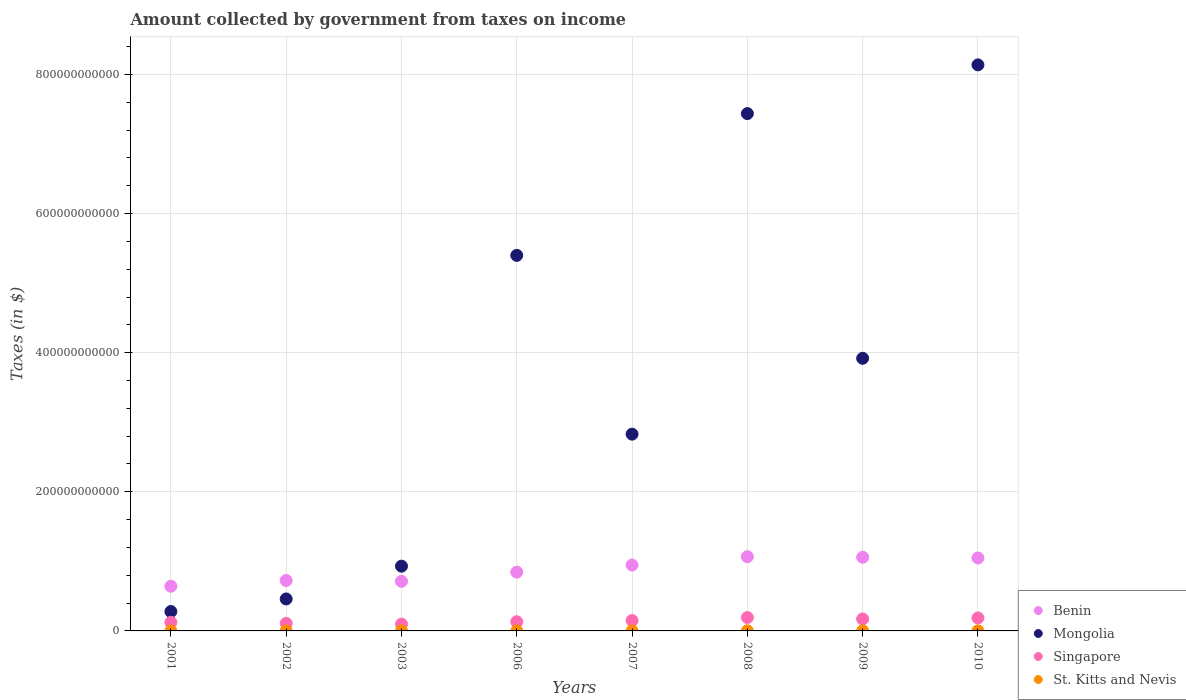How many different coloured dotlines are there?
Give a very brief answer. 4. Is the number of dotlines equal to the number of legend labels?
Provide a succinct answer. Yes. What is the amount collected by government from taxes on income in Benin in 2010?
Give a very brief answer. 1.05e+11. Across all years, what is the maximum amount collected by government from taxes on income in St. Kitts and Nevis?
Give a very brief answer. 1.48e+08. Across all years, what is the minimum amount collected by government from taxes on income in Mongolia?
Make the answer very short. 2.79e+1. In which year was the amount collected by government from taxes on income in Benin maximum?
Provide a succinct answer. 2008. In which year was the amount collected by government from taxes on income in Singapore minimum?
Provide a succinct answer. 2003. What is the total amount collected by government from taxes on income in St. Kitts and Nevis in the graph?
Your answer should be compact. 7.73e+08. What is the difference between the amount collected by government from taxes on income in Singapore in 2003 and that in 2010?
Offer a terse response. -8.86e+09. What is the difference between the amount collected by government from taxes on income in Singapore in 2002 and the amount collected by government from taxes on income in Benin in 2001?
Make the answer very short. -5.34e+1. What is the average amount collected by government from taxes on income in Mongolia per year?
Ensure brevity in your answer.  3.67e+11. In the year 2010, what is the difference between the amount collected by government from taxes on income in Singapore and amount collected by government from taxes on income in Mongolia?
Offer a very short reply. -7.95e+11. In how many years, is the amount collected by government from taxes on income in Benin greater than 400000000000 $?
Your answer should be very brief. 0. What is the ratio of the amount collected by government from taxes on income in Benin in 2002 to that in 2003?
Make the answer very short. 1.02. Is the amount collected by government from taxes on income in Singapore in 2001 less than that in 2007?
Give a very brief answer. Yes. What is the difference between the highest and the second highest amount collected by government from taxes on income in Benin?
Your answer should be very brief. 8.11e+08. What is the difference between the highest and the lowest amount collected by government from taxes on income in Singapore?
Your response must be concise. 9.47e+09. In how many years, is the amount collected by government from taxes on income in St. Kitts and Nevis greater than the average amount collected by government from taxes on income in St. Kitts and Nevis taken over all years?
Offer a terse response. 4. Does the amount collected by government from taxes on income in Benin monotonically increase over the years?
Give a very brief answer. No. Is the amount collected by government from taxes on income in Mongolia strictly less than the amount collected by government from taxes on income in Benin over the years?
Your answer should be very brief. No. How many years are there in the graph?
Keep it short and to the point. 8. What is the difference between two consecutive major ticks on the Y-axis?
Your response must be concise. 2.00e+11. Where does the legend appear in the graph?
Offer a terse response. Bottom right. How are the legend labels stacked?
Provide a succinct answer. Vertical. What is the title of the graph?
Keep it short and to the point. Amount collected by government from taxes on income. Does "Pacific island small states" appear as one of the legend labels in the graph?
Ensure brevity in your answer.  No. What is the label or title of the X-axis?
Offer a terse response. Years. What is the label or title of the Y-axis?
Provide a succinct answer. Taxes (in $). What is the Taxes (in $) in Benin in 2001?
Your answer should be compact. 6.43e+1. What is the Taxes (in $) of Mongolia in 2001?
Keep it short and to the point. 2.79e+1. What is the Taxes (in $) in Singapore in 2001?
Offer a terse response. 1.24e+1. What is the Taxes (in $) in St. Kitts and Nevis in 2001?
Provide a short and direct response. 5.77e+07. What is the Taxes (in $) in Benin in 2002?
Your response must be concise. 7.25e+1. What is the Taxes (in $) of Mongolia in 2002?
Provide a succinct answer. 4.60e+1. What is the Taxes (in $) of Singapore in 2002?
Make the answer very short. 1.09e+1. What is the Taxes (in $) in St. Kitts and Nevis in 2002?
Provide a succinct answer. 6.19e+07. What is the Taxes (in $) in Benin in 2003?
Make the answer very short. 7.13e+1. What is the Taxes (in $) of Mongolia in 2003?
Offer a terse response. 9.31e+1. What is the Taxes (in $) of Singapore in 2003?
Make the answer very short. 9.78e+09. What is the Taxes (in $) of St. Kitts and Nevis in 2003?
Your answer should be compact. 6.41e+07. What is the Taxes (in $) in Benin in 2006?
Provide a succinct answer. 8.45e+1. What is the Taxes (in $) of Mongolia in 2006?
Your answer should be compact. 5.40e+11. What is the Taxes (in $) of Singapore in 2006?
Offer a terse response. 1.32e+1. What is the Taxes (in $) of St. Kitts and Nevis in 2006?
Offer a terse response. 9.84e+07. What is the Taxes (in $) of Benin in 2007?
Offer a terse response. 9.47e+1. What is the Taxes (in $) of Mongolia in 2007?
Make the answer very short. 2.83e+11. What is the Taxes (in $) of Singapore in 2007?
Offer a very short reply. 1.49e+1. What is the Taxes (in $) of St. Kitts and Nevis in 2007?
Provide a succinct answer. 1.16e+08. What is the Taxes (in $) of Benin in 2008?
Keep it short and to the point. 1.07e+11. What is the Taxes (in $) in Mongolia in 2008?
Give a very brief answer. 7.44e+11. What is the Taxes (in $) in Singapore in 2008?
Your answer should be compact. 1.93e+1. What is the Taxes (in $) in St. Kitts and Nevis in 2008?
Your response must be concise. 1.35e+08. What is the Taxes (in $) in Benin in 2009?
Keep it short and to the point. 1.06e+11. What is the Taxes (in $) in Mongolia in 2009?
Provide a succinct answer. 3.92e+11. What is the Taxes (in $) of Singapore in 2009?
Provide a short and direct response. 1.72e+1. What is the Taxes (in $) in St. Kitts and Nevis in 2009?
Your answer should be very brief. 1.48e+08. What is the Taxes (in $) in Benin in 2010?
Offer a very short reply. 1.05e+11. What is the Taxes (in $) of Mongolia in 2010?
Give a very brief answer. 8.14e+11. What is the Taxes (in $) of Singapore in 2010?
Provide a short and direct response. 1.86e+1. What is the Taxes (in $) in St. Kitts and Nevis in 2010?
Your response must be concise. 9.26e+07. Across all years, what is the maximum Taxes (in $) of Benin?
Make the answer very short. 1.07e+11. Across all years, what is the maximum Taxes (in $) in Mongolia?
Make the answer very short. 8.14e+11. Across all years, what is the maximum Taxes (in $) of Singapore?
Ensure brevity in your answer.  1.93e+1. Across all years, what is the maximum Taxes (in $) in St. Kitts and Nevis?
Make the answer very short. 1.48e+08. Across all years, what is the minimum Taxes (in $) in Benin?
Your response must be concise. 6.43e+1. Across all years, what is the minimum Taxes (in $) of Mongolia?
Provide a short and direct response. 2.79e+1. Across all years, what is the minimum Taxes (in $) of Singapore?
Your answer should be compact. 9.78e+09. Across all years, what is the minimum Taxes (in $) of St. Kitts and Nevis?
Offer a terse response. 5.77e+07. What is the total Taxes (in $) of Benin in the graph?
Provide a short and direct response. 7.05e+11. What is the total Taxes (in $) of Mongolia in the graph?
Provide a succinct answer. 2.94e+12. What is the total Taxes (in $) of Singapore in the graph?
Ensure brevity in your answer.  1.16e+11. What is the total Taxes (in $) of St. Kitts and Nevis in the graph?
Ensure brevity in your answer.  7.73e+08. What is the difference between the Taxes (in $) in Benin in 2001 and that in 2002?
Give a very brief answer. -8.23e+09. What is the difference between the Taxes (in $) of Mongolia in 2001 and that in 2002?
Make the answer very short. -1.81e+1. What is the difference between the Taxes (in $) of Singapore in 2001 and that in 2002?
Offer a very short reply. 1.50e+09. What is the difference between the Taxes (in $) in St. Kitts and Nevis in 2001 and that in 2002?
Ensure brevity in your answer.  -4.20e+06. What is the difference between the Taxes (in $) in Benin in 2001 and that in 2003?
Keep it short and to the point. -7.04e+09. What is the difference between the Taxes (in $) in Mongolia in 2001 and that in 2003?
Give a very brief answer. -6.52e+1. What is the difference between the Taxes (in $) of Singapore in 2001 and that in 2003?
Your answer should be compact. 2.59e+09. What is the difference between the Taxes (in $) of St. Kitts and Nevis in 2001 and that in 2003?
Your response must be concise. -6.40e+06. What is the difference between the Taxes (in $) of Benin in 2001 and that in 2006?
Keep it short and to the point. -2.03e+1. What is the difference between the Taxes (in $) of Mongolia in 2001 and that in 2006?
Offer a terse response. -5.12e+11. What is the difference between the Taxes (in $) of Singapore in 2001 and that in 2006?
Your answer should be compact. -8.12e+08. What is the difference between the Taxes (in $) in St. Kitts and Nevis in 2001 and that in 2006?
Keep it short and to the point. -4.07e+07. What is the difference between the Taxes (in $) of Benin in 2001 and that in 2007?
Provide a succinct answer. -3.04e+1. What is the difference between the Taxes (in $) in Mongolia in 2001 and that in 2007?
Offer a very short reply. -2.55e+11. What is the difference between the Taxes (in $) in Singapore in 2001 and that in 2007?
Your answer should be compact. -2.57e+09. What is the difference between the Taxes (in $) in St. Kitts and Nevis in 2001 and that in 2007?
Your response must be concise. -5.83e+07. What is the difference between the Taxes (in $) of Benin in 2001 and that in 2008?
Provide a short and direct response. -4.24e+1. What is the difference between the Taxes (in $) in Mongolia in 2001 and that in 2008?
Offer a very short reply. -7.16e+11. What is the difference between the Taxes (in $) in Singapore in 2001 and that in 2008?
Your answer should be compact. -6.89e+09. What is the difference between the Taxes (in $) in St. Kitts and Nevis in 2001 and that in 2008?
Offer a very short reply. -7.71e+07. What is the difference between the Taxes (in $) in Benin in 2001 and that in 2009?
Give a very brief answer. -4.16e+1. What is the difference between the Taxes (in $) in Mongolia in 2001 and that in 2009?
Give a very brief answer. -3.64e+11. What is the difference between the Taxes (in $) in Singapore in 2001 and that in 2009?
Ensure brevity in your answer.  -4.81e+09. What is the difference between the Taxes (in $) in St. Kitts and Nevis in 2001 and that in 2009?
Ensure brevity in your answer.  -8.99e+07. What is the difference between the Taxes (in $) in Benin in 2001 and that in 2010?
Give a very brief answer. -4.06e+1. What is the difference between the Taxes (in $) in Mongolia in 2001 and that in 2010?
Ensure brevity in your answer.  -7.86e+11. What is the difference between the Taxes (in $) in Singapore in 2001 and that in 2010?
Provide a succinct answer. -6.28e+09. What is the difference between the Taxes (in $) in St. Kitts and Nevis in 2001 and that in 2010?
Give a very brief answer. -3.49e+07. What is the difference between the Taxes (in $) in Benin in 2002 and that in 2003?
Your answer should be very brief. 1.19e+09. What is the difference between the Taxes (in $) in Mongolia in 2002 and that in 2003?
Make the answer very short. -4.71e+1. What is the difference between the Taxes (in $) in Singapore in 2002 and that in 2003?
Your answer should be very brief. 1.09e+09. What is the difference between the Taxes (in $) in St. Kitts and Nevis in 2002 and that in 2003?
Ensure brevity in your answer.  -2.20e+06. What is the difference between the Taxes (in $) of Benin in 2002 and that in 2006?
Provide a succinct answer. -1.20e+1. What is the difference between the Taxes (in $) in Mongolia in 2002 and that in 2006?
Your response must be concise. -4.94e+11. What is the difference between the Taxes (in $) in Singapore in 2002 and that in 2006?
Provide a succinct answer. -2.31e+09. What is the difference between the Taxes (in $) in St. Kitts and Nevis in 2002 and that in 2006?
Your answer should be compact. -3.65e+07. What is the difference between the Taxes (in $) in Benin in 2002 and that in 2007?
Make the answer very short. -2.22e+1. What is the difference between the Taxes (in $) in Mongolia in 2002 and that in 2007?
Your response must be concise. -2.37e+11. What is the difference between the Taxes (in $) in Singapore in 2002 and that in 2007?
Ensure brevity in your answer.  -4.07e+09. What is the difference between the Taxes (in $) in St. Kitts and Nevis in 2002 and that in 2007?
Keep it short and to the point. -5.41e+07. What is the difference between the Taxes (in $) in Benin in 2002 and that in 2008?
Your response must be concise. -3.42e+1. What is the difference between the Taxes (in $) of Mongolia in 2002 and that in 2008?
Offer a very short reply. -6.98e+11. What is the difference between the Taxes (in $) in Singapore in 2002 and that in 2008?
Your response must be concise. -8.39e+09. What is the difference between the Taxes (in $) in St. Kitts and Nevis in 2002 and that in 2008?
Your response must be concise. -7.29e+07. What is the difference between the Taxes (in $) of Benin in 2002 and that in 2009?
Your response must be concise. -3.34e+1. What is the difference between the Taxes (in $) in Mongolia in 2002 and that in 2009?
Provide a short and direct response. -3.46e+11. What is the difference between the Taxes (in $) of Singapore in 2002 and that in 2009?
Ensure brevity in your answer.  -6.31e+09. What is the difference between the Taxes (in $) in St. Kitts and Nevis in 2002 and that in 2009?
Provide a succinct answer. -8.57e+07. What is the difference between the Taxes (in $) in Benin in 2002 and that in 2010?
Your answer should be very brief. -3.24e+1. What is the difference between the Taxes (in $) of Mongolia in 2002 and that in 2010?
Your answer should be very brief. -7.68e+11. What is the difference between the Taxes (in $) in Singapore in 2002 and that in 2010?
Your answer should be compact. -7.77e+09. What is the difference between the Taxes (in $) in St. Kitts and Nevis in 2002 and that in 2010?
Make the answer very short. -3.07e+07. What is the difference between the Taxes (in $) in Benin in 2003 and that in 2006?
Provide a short and direct response. -1.32e+1. What is the difference between the Taxes (in $) in Mongolia in 2003 and that in 2006?
Keep it short and to the point. -4.47e+11. What is the difference between the Taxes (in $) in Singapore in 2003 and that in 2006?
Your response must be concise. -3.40e+09. What is the difference between the Taxes (in $) in St. Kitts and Nevis in 2003 and that in 2006?
Provide a succinct answer. -3.43e+07. What is the difference between the Taxes (in $) of Benin in 2003 and that in 2007?
Your answer should be very brief. -2.34e+1. What is the difference between the Taxes (in $) of Mongolia in 2003 and that in 2007?
Your answer should be compact. -1.90e+11. What is the difference between the Taxes (in $) in Singapore in 2003 and that in 2007?
Your answer should be very brief. -5.16e+09. What is the difference between the Taxes (in $) in St. Kitts and Nevis in 2003 and that in 2007?
Provide a succinct answer. -5.19e+07. What is the difference between the Taxes (in $) of Benin in 2003 and that in 2008?
Your response must be concise. -3.54e+1. What is the difference between the Taxes (in $) in Mongolia in 2003 and that in 2008?
Provide a succinct answer. -6.51e+11. What is the difference between the Taxes (in $) in Singapore in 2003 and that in 2008?
Keep it short and to the point. -9.47e+09. What is the difference between the Taxes (in $) of St. Kitts and Nevis in 2003 and that in 2008?
Provide a succinct answer. -7.07e+07. What is the difference between the Taxes (in $) of Benin in 2003 and that in 2009?
Your answer should be very brief. -3.46e+1. What is the difference between the Taxes (in $) of Mongolia in 2003 and that in 2009?
Offer a terse response. -2.99e+11. What is the difference between the Taxes (in $) of Singapore in 2003 and that in 2009?
Ensure brevity in your answer.  -7.40e+09. What is the difference between the Taxes (in $) of St. Kitts and Nevis in 2003 and that in 2009?
Offer a very short reply. -8.35e+07. What is the difference between the Taxes (in $) of Benin in 2003 and that in 2010?
Keep it short and to the point. -3.35e+1. What is the difference between the Taxes (in $) of Mongolia in 2003 and that in 2010?
Your response must be concise. -7.21e+11. What is the difference between the Taxes (in $) of Singapore in 2003 and that in 2010?
Provide a succinct answer. -8.86e+09. What is the difference between the Taxes (in $) in St. Kitts and Nevis in 2003 and that in 2010?
Offer a terse response. -2.85e+07. What is the difference between the Taxes (in $) in Benin in 2006 and that in 2007?
Give a very brief answer. -1.02e+1. What is the difference between the Taxes (in $) in Mongolia in 2006 and that in 2007?
Keep it short and to the point. 2.57e+11. What is the difference between the Taxes (in $) in Singapore in 2006 and that in 2007?
Ensure brevity in your answer.  -1.76e+09. What is the difference between the Taxes (in $) of St. Kitts and Nevis in 2006 and that in 2007?
Your answer should be compact. -1.76e+07. What is the difference between the Taxes (in $) of Benin in 2006 and that in 2008?
Make the answer very short. -2.22e+1. What is the difference between the Taxes (in $) of Mongolia in 2006 and that in 2008?
Offer a very short reply. -2.04e+11. What is the difference between the Taxes (in $) in Singapore in 2006 and that in 2008?
Keep it short and to the point. -6.08e+09. What is the difference between the Taxes (in $) in St. Kitts and Nevis in 2006 and that in 2008?
Make the answer very short. -3.64e+07. What is the difference between the Taxes (in $) of Benin in 2006 and that in 2009?
Your answer should be compact. -2.13e+1. What is the difference between the Taxes (in $) in Mongolia in 2006 and that in 2009?
Ensure brevity in your answer.  1.48e+11. What is the difference between the Taxes (in $) of Singapore in 2006 and that in 2009?
Offer a terse response. -4.00e+09. What is the difference between the Taxes (in $) of St. Kitts and Nevis in 2006 and that in 2009?
Your answer should be very brief. -4.92e+07. What is the difference between the Taxes (in $) of Benin in 2006 and that in 2010?
Your response must be concise. -2.03e+1. What is the difference between the Taxes (in $) of Mongolia in 2006 and that in 2010?
Offer a very short reply. -2.74e+11. What is the difference between the Taxes (in $) of Singapore in 2006 and that in 2010?
Your response must be concise. -5.46e+09. What is the difference between the Taxes (in $) of St. Kitts and Nevis in 2006 and that in 2010?
Make the answer very short. 5.80e+06. What is the difference between the Taxes (in $) of Benin in 2007 and that in 2008?
Ensure brevity in your answer.  -1.20e+1. What is the difference between the Taxes (in $) in Mongolia in 2007 and that in 2008?
Offer a terse response. -4.61e+11. What is the difference between the Taxes (in $) in Singapore in 2007 and that in 2008?
Keep it short and to the point. -4.32e+09. What is the difference between the Taxes (in $) of St. Kitts and Nevis in 2007 and that in 2008?
Your answer should be very brief. -1.88e+07. What is the difference between the Taxes (in $) of Benin in 2007 and that in 2009?
Provide a short and direct response. -1.12e+1. What is the difference between the Taxes (in $) of Mongolia in 2007 and that in 2009?
Ensure brevity in your answer.  -1.09e+11. What is the difference between the Taxes (in $) in Singapore in 2007 and that in 2009?
Ensure brevity in your answer.  -2.24e+09. What is the difference between the Taxes (in $) in St. Kitts and Nevis in 2007 and that in 2009?
Keep it short and to the point. -3.16e+07. What is the difference between the Taxes (in $) in Benin in 2007 and that in 2010?
Provide a short and direct response. -1.01e+1. What is the difference between the Taxes (in $) in Mongolia in 2007 and that in 2010?
Give a very brief answer. -5.31e+11. What is the difference between the Taxes (in $) of Singapore in 2007 and that in 2010?
Your answer should be very brief. -3.71e+09. What is the difference between the Taxes (in $) in St. Kitts and Nevis in 2007 and that in 2010?
Give a very brief answer. 2.34e+07. What is the difference between the Taxes (in $) in Benin in 2008 and that in 2009?
Your answer should be very brief. 8.11e+08. What is the difference between the Taxes (in $) in Mongolia in 2008 and that in 2009?
Provide a succinct answer. 3.52e+11. What is the difference between the Taxes (in $) in Singapore in 2008 and that in 2009?
Your answer should be compact. 2.08e+09. What is the difference between the Taxes (in $) of St. Kitts and Nevis in 2008 and that in 2009?
Provide a short and direct response. -1.28e+07. What is the difference between the Taxes (in $) in Benin in 2008 and that in 2010?
Your answer should be very brief. 1.84e+09. What is the difference between the Taxes (in $) of Mongolia in 2008 and that in 2010?
Keep it short and to the point. -7.00e+1. What is the difference between the Taxes (in $) in Singapore in 2008 and that in 2010?
Provide a succinct answer. 6.11e+08. What is the difference between the Taxes (in $) in St. Kitts and Nevis in 2008 and that in 2010?
Offer a terse response. 4.22e+07. What is the difference between the Taxes (in $) of Benin in 2009 and that in 2010?
Keep it short and to the point. 1.03e+09. What is the difference between the Taxes (in $) in Mongolia in 2009 and that in 2010?
Keep it short and to the point. -4.22e+11. What is the difference between the Taxes (in $) of Singapore in 2009 and that in 2010?
Keep it short and to the point. -1.47e+09. What is the difference between the Taxes (in $) in St. Kitts and Nevis in 2009 and that in 2010?
Give a very brief answer. 5.50e+07. What is the difference between the Taxes (in $) of Benin in 2001 and the Taxes (in $) of Mongolia in 2002?
Make the answer very short. 1.83e+1. What is the difference between the Taxes (in $) of Benin in 2001 and the Taxes (in $) of Singapore in 2002?
Provide a succinct answer. 5.34e+1. What is the difference between the Taxes (in $) in Benin in 2001 and the Taxes (in $) in St. Kitts and Nevis in 2002?
Ensure brevity in your answer.  6.42e+1. What is the difference between the Taxes (in $) of Mongolia in 2001 and the Taxes (in $) of Singapore in 2002?
Your response must be concise. 1.70e+1. What is the difference between the Taxes (in $) of Mongolia in 2001 and the Taxes (in $) of St. Kitts and Nevis in 2002?
Your response must be concise. 2.78e+1. What is the difference between the Taxes (in $) in Singapore in 2001 and the Taxes (in $) in St. Kitts and Nevis in 2002?
Offer a very short reply. 1.23e+1. What is the difference between the Taxes (in $) in Benin in 2001 and the Taxes (in $) in Mongolia in 2003?
Provide a succinct answer. -2.88e+1. What is the difference between the Taxes (in $) of Benin in 2001 and the Taxes (in $) of Singapore in 2003?
Keep it short and to the point. 5.45e+1. What is the difference between the Taxes (in $) of Benin in 2001 and the Taxes (in $) of St. Kitts and Nevis in 2003?
Offer a terse response. 6.42e+1. What is the difference between the Taxes (in $) of Mongolia in 2001 and the Taxes (in $) of Singapore in 2003?
Give a very brief answer. 1.81e+1. What is the difference between the Taxes (in $) of Mongolia in 2001 and the Taxes (in $) of St. Kitts and Nevis in 2003?
Offer a very short reply. 2.78e+1. What is the difference between the Taxes (in $) in Singapore in 2001 and the Taxes (in $) in St. Kitts and Nevis in 2003?
Your answer should be compact. 1.23e+1. What is the difference between the Taxes (in $) in Benin in 2001 and the Taxes (in $) in Mongolia in 2006?
Offer a terse response. -4.76e+11. What is the difference between the Taxes (in $) in Benin in 2001 and the Taxes (in $) in Singapore in 2006?
Make the answer very short. 5.11e+1. What is the difference between the Taxes (in $) in Benin in 2001 and the Taxes (in $) in St. Kitts and Nevis in 2006?
Your answer should be compact. 6.42e+1. What is the difference between the Taxes (in $) of Mongolia in 2001 and the Taxes (in $) of Singapore in 2006?
Provide a short and direct response. 1.47e+1. What is the difference between the Taxes (in $) in Mongolia in 2001 and the Taxes (in $) in St. Kitts and Nevis in 2006?
Offer a very short reply. 2.78e+1. What is the difference between the Taxes (in $) in Singapore in 2001 and the Taxes (in $) in St. Kitts and Nevis in 2006?
Provide a succinct answer. 1.23e+1. What is the difference between the Taxes (in $) of Benin in 2001 and the Taxes (in $) of Mongolia in 2007?
Make the answer very short. -2.19e+11. What is the difference between the Taxes (in $) of Benin in 2001 and the Taxes (in $) of Singapore in 2007?
Give a very brief answer. 4.93e+1. What is the difference between the Taxes (in $) of Benin in 2001 and the Taxes (in $) of St. Kitts and Nevis in 2007?
Your answer should be very brief. 6.41e+1. What is the difference between the Taxes (in $) in Mongolia in 2001 and the Taxes (in $) in Singapore in 2007?
Provide a short and direct response. 1.29e+1. What is the difference between the Taxes (in $) of Mongolia in 2001 and the Taxes (in $) of St. Kitts and Nevis in 2007?
Make the answer very short. 2.78e+1. What is the difference between the Taxes (in $) in Singapore in 2001 and the Taxes (in $) in St. Kitts and Nevis in 2007?
Your answer should be very brief. 1.23e+1. What is the difference between the Taxes (in $) of Benin in 2001 and the Taxes (in $) of Mongolia in 2008?
Your answer should be very brief. -6.79e+11. What is the difference between the Taxes (in $) of Benin in 2001 and the Taxes (in $) of Singapore in 2008?
Your answer should be very brief. 4.50e+1. What is the difference between the Taxes (in $) in Benin in 2001 and the Taxes (in $) in St. Kitts and Nevis in 2008?
Keep it short and to the point. 6.41e+1. What is the difference between the Taxes (in $) of Mongolia in 2001 and the Taxes (in $) of Singapore in 2008?
Give a very brief answer. 8.62e+09. What is the difference between the Taxes (in $) of Mongolia in 2001 and the Taxes (in $) of St. Kitts and Nevis in 2008?
Provide a succinct answer. 2.77e+1. What is the difference between the Taxes (in $) in Singapore in 2001 and the Taxes (in $) in St. Kitts and Nevis in 2008?
Offer a terse response. 1.22e+1. What is the difference between the Taxes (in $) in Benin in 2001 and the Taxes (in $) in Mongolia in 2009?
Your answer should be very brief. -3.28e+11. What is the difference between the Taxes (in $) of Benin in 2001 and the Taxes (in $) of Singapore in 2009?
Your answer should be very brief. 4.71e+1. What is the difference between the Taxes (in $) in Benin in 2001 and the Taxes (in $) in St. Kitts and Nevis in 2009?
Your response must be concise. 6.41e+1. What is the difference between the Taxes (in $) of Mongolia in 2001 and the Taxes (in $) of Singapore in 2009?
Your answer should be very brief. 1.07e+1. What is the difference between the Taxes (in $) in Mongolia in 2001 and the Taxes (in $) in St. Kitts and Nevis in 2009?
Your answer should be very brief. 2.77e+1. What is the difference between the Taxes (in $) of Singapore in 2001 and the Taxes (in $) of St. Kitts and Nevis in 2009?
Provide a short and direct response. 1.22e+1. What is the difference between the Taxes (in $) in Benin in 2001 and the Taxes (in $) in Mongolia in 2010?
Provide a short and direct response. -7.49e+11. What is the difference between the Taxes (in $) in Benin in 2001 and the Taxes (in $) in Singapore in 2010?
Your answer should be compact. 4.56e+1. What is the difference between the Taxes (in $) of Benin in 2001 and the Taxes (in $) of St. Kitts and Nevis in 2010?
Offer a very short reply. 6.42e+1. What is the difference between the Taxes (in $) in Mongolia in 2001 and the Taxes (in $) in Singapore in 2010?
Your answer should be compact. 9.23e+09. What is the difference between the Taxes (in $) in Mongolia in 2001 and the Taxes (in $) in St. Kitts and Nevis in 2010?
Your answer should be very brief. 2.78e+1. What is the difference between the Taxes (in $) in Singapore in 2001 and the Taxes (in $) in St. Kitts and Nevis in 2010?
Provide a succinct answer. 1.23e+1. What is the difference between the Taxes (in $) in Benin in 2002 and the Taxes (in $) in Mongolia in 2003?
Your answer should be very brief. -2.06e+1. What is the difference between the Taxes (in $) of Benin in 2002 and the Taxes (in $) of Singapore in 2003?
Ensure brevity in your answer.  6.27e+1. What is the difference between the Taxes (in $) in Benin in 2002 and the Taxes (in $) in St. Kitts and Nevis in 2003?
Give a very brief answer. 7.24e+1. What is the difference between the Taxes (in $) in Mongolia in 2002 and the Taxes (in $) in Singapore in 2003?
Offer a terse response. 3.62e+1. What is the difference between the Taxes (in $) of Mongolia in 2002 and the Taxes (in $) of St. Kitts and Nevis in 2003?
Ensure brevity in your answer.  4.59e+1. What is the difference between the Taxes (in $) of Singapore in 2002 and the Taxes (in $) of St. Kitts and Nevis in 2003?
Offer a very short reply. 1.08e+1. What is the difference between the Taxes (in $) of Benin in 2002 and the Taxes (in $) of Mongolia in 2006?
Your response must be concise. -4.67e+11. What is the difference between the Taxes (in $) of Benin in 2002 and the Taxes (in $) of Singapore in 2006?
Ensure brevity in your answer.  5.93e+1. What is the difference between the Taxes (in $) of Benin in 2002 and the Taxes (in $) of St. Kitts and Nevis in 2006?
Your answer should be very brief. 7.24e+1. What is the difference between the Taxes (in $) of Mongolia in 2002 and the Taxes (in $) of Singapore in 2006?
Offer a very short reply. 3.28e+1. What is the difference between the Taxes (in $) of Mongolia in 2002 and the Taxes (in $) of St. Kitts and Nevis in 2006?
Give a very brief answer. 4.59e+1. What is the difference between the Taxes (in $) in Singapore in 2002 and the Taxes (in $) in St. Kitts and Nevis in 2006?
Give a very brief answer. 1.08e+1. What is the difference between the Taxes (in $) in Benin in 2002 and the Taxes (in $) in Mongolia in 2007?
Offer a terse response. -2.10e+11. What is the difference between the Taxes (in $) in Benin in 2002 and the Taxes (in $) in Singapore in 2007?
Keep it short and to the point. 5.76e+1. What is the difference between the Taxes (in $) in Benin in 2002 and the Taxes (in $) in St. Kitts and Nevis in 2007?
Ensure brevity in your answer.  7.24e+1. What is the difference between the Taxes (in $) in Mongolia in 2002 and the Taxes (in $) in Singapore in 2007?
Offer a very short reply. 3.10e+1. What is the difference between the Taxes (in $) of Mongolia in 2002 and the Taxes (in $) of St. Kitts and Nevis in 2007?
Your response must be concise. 4.58e+1. What is the difference between the Taxes (in $) of Singapore in 2002 and the Taxes (in $) of St. Kitts and Nevis in 2007?
Give a very brief answer. 1.08e+1. What is the difference between the Taxes (in $) in Benin in 2002 and the Taxes (in $) in Mongolia in 2008?
Keep it short and to the point. -6.71e+11. What is the difference between the Taxes (in $) in Benin in 2002 and the Taxes (in $) in Singapore in 2008?
Your response must be concise. 5.32e+1. What is the difference between the Taxes (in $) of Benin in 2002 and the Taxes (in $) of St. Kitts and Nevis in 2008?
Provide a short and direct response. 7.24e+1. What is the difference between the Taxes (in $) of Mongolia in 2002 and the Taxes (in $) of Singapore in 2008?
Your answer should be compact. 2.67e+1. What is the difference between the Taxes (in $) in Mongolia in 2002 and the Taxes (in $) in St. Kitts and Nevis in 2008?
Your answer should be very brief. 4.58e+1. What is the difference between the Taxes (in $) in Singapore in 2002 and the Taxes (in $) in St. Kitts and Nevis in 2008?
Offer a terse response. 1.07e+1. What is the difference between the Taxes (in $) of Benin in 2002 and the Taxes (in $) of Mongolia in 2009?
Your answer should be very brief. -3.19e+11. What is the difference between the Taxes (in $) of Benin in 2002 and the Taxes (in $) of Singapore in 2009?
Provide a succinct answer. 5.53e+1. What is the difference between the Taxes (in $) in Benin in 2002 and the Taxes (in $) in St. Kitts and Nevis in 2009?
Make the answer very short. 7.23e+1. What is the difference between the Taxes (in $) of Mongolia in 2002 and the Taxes (in $) of Singapore in 2009?
Your answer should be very brief. 2.88e+1. What is the difference between the Taxes (in $) of Mongolia in 2002 and the Taxes (in $) of St. Kitts and Nevis in 2009?
Ensure brevity in your answer.  4.58e+1. What is the difference between the Taxes (in $) of Singapore in 2002 and the Taxes (in $) of St. Kitts and Nevis in 2009?
Provide a succinct answer. 1.07e+1. What is the difference between the Taxes (in $) of Benin in 2002 and the Taxes (in $) of Mongolia in 2010?
Give a very brief answer. -7.41e+11. What is the difference between the Taxes (in $) in Benin in 2002 and the Taxes (in $) in Singapore in 2010?
Offer a very short reply. 5.38e+1. What is the difference between the Taxes (in $) in Benin in 2002 and the Taxes (in $) in St. Kitts and Nevis in 2010?
Make the answer very short. 7.24e+1. What is the difference between the Taxes (in $) in Mongolia in 2002 and the Taxes (in $) in Singapore in 2010?
Offer a terse response. 2.73e+1. What is the difference between the Taxes (in $) in Mongolia in 2002 and the Taxes (in $) in St. Kitts and Nevis in 2010?
Provide a short and direct response. 4.59e+1. What is the difference between the Taxes (in $) in Singapore in 2002 and the Taxes (in $) in St. Kitts and Nevis in 2010?
Give a very brief answer. 1.08e+1. What is the difference between the Taxes (in $) in Benin in 2003 and the Taxes (in $) in Mongolia in 2006?
Your response must be concise. -4.69e+11. What is the difference between the Taxes (in $) in Benin in 2003 and the Taxes (in $) in Singapore in 2006?
Make the answer very short. 5.81e+1. What is the difference between the Taxes (in $) of Benin in 2003 and the Taxes (in $) of St. Kitts and Nevis in 2006?
Give a very brief answer. 7.12e+1. What is the difference between the Taxes (in $) in Mongolia in 2003 and the Taxes (in $) in Singapore in 2006?
Give a very brief answer. 7.99e+1. What is the difference between the Taxes (in $) in Mongolia in 2003 and the Taxes (in $) in St. Kitts and Nevis in 2006?
Provide a short and direct response. 9.30e+1. What is the difference between the Taxes (in $) of Singapore in 2003 and the Taxes (in $) of St. Kitts and Nevis in 2006?
Give a very brief answer. 9.68e+09. What is the difference between the Taxes (in $) of Benin in 2003 and the Taxes (in $) of Mongolia in 2007?
Your response must be concise. -2.12e+11. What is the difference between the Taxes (in $) of Benin in 2003 and the Taxes (in $) of Singapore in 2007?
Make the answer very short. 5.64e+1. What is the difference between the Taxes (in $) in Benin in 2003 and the Taxes (in $) in St. Kitts and Nevis in 2007?
Give a very brief answer. 7.12e+1. What is the difference between the Taxes (in $) of Mongolia in 2003 and the Taxes (in $) of Singapore in 2007?
Offer a very short reply. 7.82e+1. What is the difference between the Taxes (in $) of Mongolia in 2003 and the Taxes (in $) of St. Kitts and Nevis in 2007?
Give a very brief answer. 9.30e+1. What is the difference between the Taxes (in $) in Singapore in 2003 and the Taxes (in $) in St. Kitts and Nevis in 2007?
Your answer should be very brief. 9.67e+09. What is the difference between the Taxes (in $) of Benin in 2003 and the Taxes (in $) of Mongolia in 2008?
Your answer should be compact. -6.72e+11. What is the difference between the Taxes (in $) of Benin in 2003 and the Taxes (in $) of Singapore in 2008?
Keep it short and to the point. 5.20e+1. What is the difference between the Taxes (in $) in Benin in 2003 and the Taxes (in $) in St. Kitts and Nevis in 2008?
Your answer should be very brief. 7.12e+1. What is the difference between the Taxes (in $) in Mongolia in 2003 and the Taxes (in $) in Singapore in 2008?
Provide a short and direct response. 7.38e+1. What is the difference between the Taxes (in $) in Mongolia in 2003 and the Taxes (in $) in St. Kitts and Nevis in 2008?
Give a very brief answer. 9.30e+1. What is the difference between the Taxes (in $) in Singapore in 2003 and the Taxes (in $) in St. Kitts and Nevis in 2008?
Offer a terse response. 9.65e+09. What is the difference between the Taxes (in $) in Benin in 2003 and the Taxes (in $) in Mongolia in 2009?
Provide a short and direct response. -3.21e+11. What is the difference between the Taxes (in $) in Benin in 2003 and the Taxes (in $) in Singapore in 2009?
Offer a terse response. 5.41e+1. What is the difference between the Taxes (in $) of Benin in 2003 and the Taxes (in $) of St. Kitts and Nevis in 2009?
Offer a terse response. 7.12e+1. What is the difference between the Taxes (in $) of Mongolia in 2003 and the Taxes (in $) of Singapore in 2009?
Your answer should be very brief. 7.59e+1. What is the difference between the Taxes (in $) of Mongolia in 2003 and the Taxes (in $) of St. Kitts and Nevis in 2009?
Provide a succinct answer. 9.29e+1. What is the difference between the Taxes (in $) of Singapore in 2003 and the Taxes (in $) of St. Kitts and Nevis in 2009?
Give a very brief answer. 9.64e+09. What is the difference between the Taxes (in $) of Benin in 2003 and the Taxes (in $) of Mongolia in 2010?
Offer a very short reply. -7.42e+11. What is the difference between the Taxes (in $) of Benin in 2003 and the Taxes (in $) of Singapore in 2010?
Offer a very short reply. 5.27e+1. What is the difference between the Taxes (in $) of Benin in 2003 and the Taxes (in $) of St. Kitts and Nevis in 2010?
Keep it short and to the point. 7.12e+1. What is the difference between the Taxes (in $) of Mongolia in 2003 and the Taxes (in $) of Singapore in 2010?
Offer a terse response. 7.44e+1. What is the difference between the Taxes (in $) in Mongolia in 2003 and the Taxes (in $) in St. Kitts and Nevis in 2010?
Provide a succinct answer. 9.30e+1. What is the difference between the Taxes (in $) of Singapore in 2003 and the Taxes (in $) of St. Kitts and Nevis in 2010?
Your response must be concise. 9.69e+09. What is the difference between the Taxes (in $) in Benin in 2006 and the Taxes (in $) in Mongolia in 2007?
Your answer should be very brief. -1.98e+11. What is the difference between the Taxes (in $) of Benin in 2006 and the Taxes (in $) of Singapore in 2007?
Your response must be concise. 6.96e+1. What is the difference between the Taxes (in $) in Benin in 2006 and the Taxes (in $) in St. Kitts and Nevis in 2007?
Provide a succinct answer. 8.44e+1. What is the difference between the Taxes (in $) in Mongolia in 2006 and the Taxes (in $) in Singapore in 2007?
Make the answer very short. 5.25e+11. What is the difference between the Taxes (in $) of Mongolia in 2006 and the Taxes (in $) of St. Kitts and Nevis in 2007?
Provide a short and direct response. 5.40e+11. What is the difference between the Taxes (in $) in Singapore in 2006 and the Taxes (in $) in St. Kitts and Nevis in 2007?
Offer a very short reply. 1.31e+1. What is the difference between the Taxes (in $) of Benin in 2006 and the Taxes (in $) of Mongolia in 2008?
Keep it short and to the point. -6.59e+11. What is the difference between the Taxes (in $) of Benin in 2006 and the Taxes (in $) of Singapore in 2008?
Your answer should be very brief. 6.53e+1. What is the difference between the Taxes (in $) in Benin in 2006 and the Taxes (in $) in St. Kitts and Nevis in 2008?
Give a very brief answer. 8.44e+1. What is the difference between the Taxes (in $) in Mongolia in 2006 and the Taxes (in $) in Singapore in 2008?
Your response must be concise. 5.21e+11. What is the difference between the Taxes (in $) of Mongolia in 2006 and the Taxes (in $) of St. Kitts and Nevis in 2008?
Keep it short and to the point. 5.40e+11. What is the difference between the Taxes (in $) of Singapore in 2006 and the Taxes (in $) of St. Kitts and Nevis in 2008?
Offer a terse response. 1.30e+1. What is the difference between the Taxes (in $) in Benin in 2006 and the Taxes (in $) in Mongolia in 2009?
Give a very brief answer. -3.07e+11. What is the difference between the Taxes (in $) of Benin in 2006 and the Taxes (in $) of Singapore in 2009?
Your response must be concise. 6.74e+1. What is the difference between the Taxes (in $) in Benin in 2006 and the Taxes (in $) in St. Kitts and Nevis in 2009?
Provide a succinct answer. 8.44e+1. What is the difference between the Taxes (in $) in Mongolia in 2006 and the Taxes (in $) in Singapore in 2009?
Provide a succinct answer. 5.23e+11. What is the difference between the Taxes (in $) of Mongolia in 2006 and the Taxes (in $) of St. Kitts and Nevis in 2009?
Give a very brief answer. 5.40e+11. What is the difference between the Taxes (in $) of Singapore in 2006 and the Taxes (in $) of St. Kitts and Nevis in 2009?
Provide a short and direct response. 1.30e+1. What is the difference between the Taxes (in $) of Benin in 2006 and the Taxes (in $) of Mongolia in 2010?
Provide a succinct answer. -7.29e+11. What is the difference between the Taxes (in $) of Benin in 2006 and the Taxes (in $) of Singapore in 2010?
Provide a succinct answer. 6.59e+1. What is the difference between the Taxes (in $) in Benin in 2006 and the Taxes (in $) in St. Kitts and Nevis in 2010?
Provide a short and direct response. 8.44e+1. What is the difference between the Taxes (in $) of Mongolia in 2006 and the Taxes (in $) of Singapore in 2010?
Keep it short and to the point. 5.21e+11. What is the difference between the Taxes (in $) of Mongolia in 2006 and the Taxes (in $) of St. Kitts and Nevis in 2010?
Ensure brevity in your answer.  5.40e+11. What is the difference between the Taxes (in $) in Singapore in 2006 and the Taxes (in $) in St. Kitts and Nevis in 2010?
Your answer should be very brief. 1.31e+1. What is the difference between the Taxes (in $) of Benin in 2007 and the Taxes (in $) of Mongolia in 2008?
Your answer should be compact. -6.49e+11. What is the difference between the Taxes (in $) in Benin in 2007 and the Taxes (in $) in Singapore in 2008?
Your answer should be compact. 7.54e+1. What is the difference between the Taxes (in $) in Benin in 2007 and the Taxes (in $) in St. Kitts and Nevis in 2008?
Offer a very short reply. 9.46e+1. What is the difference between the Taxes (in $) in Mongolia in 2007 and the Taxes (in $) in Singapore in 2008?
Make the answer very short. 2.64e+11. What is the difference between the Taxes (in $) in Mongolia in 2007 and the Taxes (in $) in St. Kitts and Nevis in 2008?
Ensure brevity in your answer.  2.83e+11. What is the difference between the Taxes (in $) of Singapore in 2007 and the Taxes (in $) of St. Kitts and Nevis in 2008?
Provide a short and direct response. 1.48e+1. What is the difference between the Taxes (in $) of Benin in 2007 and the Taxes (in $) of Mongolia in 2009?
Provide a succinct answer. -2.97e+11. What is the difference between the Taxes (in $) in Benin in 2007 and the Taxes (in $) in Singapore in 2009?
Provide a succinct answer. 7.75e+1. What is the difference between the Taxes (in $) in Benin in 2007 and the Taxes (in $) in St. Kitts and Nevis in 2009?
Ensure brevity in your answer.  9.46e+1. What is the difference between the Taxes (in $) in Mongolia in 2007 and the Taxes (in $) in Singapore in 2009?
Keep it short and to the point. 2.66e+11. What is the difference between the Taxes (in $) in Mongolia in 2007 and the Taxes (in $) in St. Kitts and Nevis in 2009?
Your answer should be compact. 2.83e+11. What is the difference between the Taxes (in $) of Singapore in 2007 and the Taxes (in $) of St. Kitts and Nevis in 2009?
Your answer should be very brief. 1.48e+1. What is the difference between the Taxes (in $) in Benin in 2007 and the Taxes (in $) in Mongolia in 2010?
Provide a short and direct response. -7.19e+11. What is the difference between the Taxes (in $) in Benin in 2007 and the Taxes (in $) in Singapore in 2010?
Ensure brevity in your answer.  7.61e+1. What is the difference between the Taxes (in $) of Benin in 2007 and the Taxes (in $) of St. Kitts and Nevis in 2010?
Your answer should be very brief. 9.46e+1. What is the difference between the Taxes (in $) in Mongolia in 2007 and the Taxes (in $) in Singapore in 2010?
Keep it short and to the point. 2.64e+11. What is the difference between the Taxes (in $) in Mongolia in 2007 and the Taxes (in $) in St. Kitts and Nevis in 2010?
Make the answer very short. 2.83e+11. What is the difference between the Taxes (in $) of Singapore in 2007 and the Taxes (in $) of St. Kitts and Nevis in 2010?
Offer a terse response. 1.48e+1. What is the difference between the Taxes (in $) in Benin in 2008 and the Taxes (in $) in Mongolia in 2009?
Provide a short and direct response. -2.85e+11. What is the difference between the Taxes (in $) of Benin in 2008 and the Taxes (in $) of Singapore in 2009?
Provide a short and direct response. 8.95e+1. What is the difference between the Taxes (in $) of Benin in 2008 and the Taxes (in $) of St. Kitts and Nevis in 2009?
Make the answer very short. 1.07e+11. What is the difference between the Taxes (in $) in Mongolia in 2008 and the Taxes (in $) in Singapore in 2009?
Make the answer very short. 7.27e+11. What is the difference between the Taxes (in $) in Mongolia in 2008 and the Taxes (in $) in St. Kitts and Nevis in 2009?
Ensure brevity in your answer.  7.44e+11. What is the difference between the Taxes (in $) of Singapore in 2008 and the Taxes (in $) of St. Kitts and Nevis in 2009?
Ensure brevity in your answer.  1.91e+1. What is the difference between the Taxes (in $) in Benin in 2008 and the Taxes (in $) in Mongolia in 2010?
Ensure brevity in your answer.  -7.07e+11. What is the difference between the Taxes (in $) in Benin in 2008 and the Taxes (in $) in Singapore in 2010?
Your answer should be very brief. 8.80e+1. What is the difference between the Taxes (in $) in Benin in 2008 and the Taxes (in $) in St. Kitts and Nevis in 2010?
Keep it short and to the point. 1.07e+11. What is the difference between the Taxes (in $) of Mongolia in 2008 and the Taxes (in $) of Singapore in 2010?
Your answer should be compact. 7.25e+11. What is the difference between the Taxes (in $) in Mongolia in 2008 and the Taxes (in $) in St. Kitts and Nevis in 2010?
Offer a terse response. 7.44e+11. What is the difference between the Taxes (in $) of Singapore in 2008 and the Taxes (in $) of St. Kitts and Nevis in 2010?
Make the answer very short. 1.92e+1. What is the difference between the Taxes (in $) in Benin in 2009 and the Taxes (in $) in Mongolia in 2010?
Provide a succinct answer. -7.08e+11. What is the difference between the Taxes (in $) in Benin in 2009 and the Taxes (in $) in Singapore in 2010?
Make the answer very short. 8.72e+1. What is the difference between the Taxes (in $) of Benin in 2009 and the Taxes (in $) of St. Kitts and Nevis in 2010?
Make the answer very short. 1.06e+11. What is the difference between the Taxes (in $) in Mongolia in 2009 and the Taxes (in $) in Singapore in 2010?
Your answer should be very brief. 3.73e+11. What is the difference between the Taxes (in $) of Mongolia in 2009 and the Taxes (in $) of St. Kitts and Nevis in 2010?
Make the answer very short. 3.92e+11. What is the difference between the Taxes (in $) of Singapore in 2009 and the Taxes (in $) of St. Kitts and Nevis in 2010?
Give a very brief answer. 1.71e+1. What is the average Taxes (in $) in Benin per year?
Offer a very short reply. 8.81e+1. What is the average Taxes (in $) of Mongolia per year?
Your response must be concise. 3.67e+11. What is the average Taxes (in $) in Singapore per year?
Your response must be concise. 1.45e+1. What is the average Taxes (in $) in St. Kitts and Nevis per year?
Make the answer very short. 9.66e+07. In the year 2001, what is the difference between the Taxes (in $) of Benin and Taxes (in $) of Mongolia?
Provide a succinct answer. 3.64e+1. In the year 2001, what is the difference between the Taxes (in $) in Benin and Taxes (in $) in Singapore?
Keep it short and to the point. 5.19e+1. In the year 2001, what is the difference between the Taxes (in $) in Benin and Taxes (in $) in St. Kitts and Nevis?
Make the answer very short. 6.42e+1. In the year 2001, what is the difference between the Taxes (in $) of Mongolia and Taxes (in $) of Singapore?
Make the answer very short. 1.55e+1. In the year 2001, what is the difference between the Taxes (in $) of Mongolia and Taxes (in $) of St. Kitts and Nevis?
Your response must be concise. 2.78e+1. In the year 2001, what is the difference between the Taxes (in $) of Singapore and Taxes (in $) of St. Kitts and Nevis?
Keep it short and to the point. 1.23e+1. In the year 2002, what is the difference between the Taxes (in $) of Benin and Taxes (in $) of Mongolia?
Your response must be concise. 2.65e+1. In the year 2002, what is the difference between the Taxes (in $) in Benin and Taxes (in $) in Singapore?
Provide a succinct answer. 6.16e+1. In the year 2002, what is the difference between the Taxes (in $) of Benin and Taxes (in $) of St. Kitts and Nevis?
Offer a terse response. 7.24e+1. In the year 2002, what is the difference between the Taxes (in $) in Mongolia and Taxes (in $) in Singapore?
Give a very brief answer. 3.51e+1. In the year 2002, what is the difference between the Taxes (in $) of Mongolia and Taxes (in $) of St. Kitts and Nevis?
Provide a short and direct response. 4.59e+1. In the year 2002, what is the difference between the Taxes (in $) of Singapore and Taxes (in $) of St. Kitts and Nevis?
Ensure brevity in your answer.  1.08e+1. In the year 2003, what is the difference between the Taxes (in $) in Benin and Taxes (in $) in Mongolia?
Provide a short and direct response. -2.18e+1. In the year 2003, what is the difference between the Taxes (in $) of Benin and Taxes (in $) of Singapore?
Offer a terse response. 6.15e+1. In the year 2003, what is the difference between the Taxes (in $) in Benin and Taxes (in $) in St. Kitts and Nevis?
Offer a very short reply. 7.12e+1. In the year 2003, what is the difference between the Taxes (in $) of Mongolia and Taxes (in $) of Singapore?
Offer a terse response. 8.33e+1. In the year 2003, what is the difference between the Taxes (in $) of Mongolia and Taxes (in $) of St. Kitts and Nevis?
Provide a succinct answer. 9.30e+1. In the year 2003, what is the difference between the Taxes (in $) in Singapore and Taxes (in $) in St. Kitts and Nevis?
Give a very brief answer. 9.72e+09. In the year 2006, what is the difference between the Taxes (in $) of Benin and Taxes (in $) of Mongolia?
Provide a succinct answer. -4.55e+11. In the year 2006, what is the difference between the Taxes (in $) in Benin and Taxes (in $) in Singapore?
Keep it short and to the point. 7.14e+1. In the year 2006, what is the difference between the Taxes (in $) in Benin and Taxes (in $) in St. Kitts and Nevis?
Provide a succinct answer. 8.44e+1. In the year 2006, what is the difference between the Taxes (in $) of Mongolia and Taxes (in $) of Singapore?
Keep it short and to the point. 5.27e+11. In the year 2006, what is the difference between the Taxes (in $) of Mongolia and Taxes (in $) of St. Kitts and Nevis?
Your response must be concise. 5.40e+11. In the year 2006, what is the difference between the Taxes (in $) in Singapore and Taxes (in $) in St. Kitts and Nevis?
Provide a short and direct response. 1.31e+1. In the year 2007, what is the difference between the Taxes (in $) of Benin and Taxes (in $) of Mongolia?
Your answer should be compact. -1.88e+11. In the year 2007, what is the difference between the Taxes (in $) of Benin and Taxes (in $) of Singapore?
Provide a short and direct response. 7.98e+1. In the year 2007, what is the difference between the Taxes (in $) of Benin and Taxes (in $) of St. Kitts and Nevis?
Offer a very short reply. 9.46e+1. In the year 2007, what is the difference between the Taxes (in $) of Mongolia and Taxes (in $) of Singapore?
Offer a terse response. 2.68e+11. In the year 2007, what is the difference between the Taxes (in $) of Mongolia and Taxes (in $) of St. Kitts and Nevis?
Offer a very short reply. 2.83e+11. In the year 2007, what is the difference between the Taxes (in $) of Singapore and Taxes (in $) of St. Kitts and Nevis?
Your answer should be very brief. 1.48e+1. In the year 2008, what is the difference between the Taxes (in $) in Benin and Taxes (in $) in Mongolia?
Give a very brief answer. -6.37e+11. In the year 2008, what is the difference between the Taxes (in $) in Benin and Taxes (in $) in Singapore?
Make the answer very short. 8.74e+1. In the year 2008, what is the difference between the Taxes (in $) of Benin and Taxes (in $) of St. Kitts and Nevis?
Your answer should be very brief. 1.07e+11. In the year 2008, what is the difference between the Taxes (in $) of Mongolia and Taxes (in $) of Singapore?
Offer a terse response. 7.24e+11. In the year 2008, what is the difference between the Taxes (in $) of Mongolia and Taxes (in $) of St. Kitts and Nevis?
Your response must be concise. 7.44e+11. In the year 2008, what is the difference between the Taxes (in $) of Singapore and Taxes (in $) of St. Kitts and Nevis?
Offer a very short reply. 1.91e+1. In the year 2009, what is the difference between the Taxes (in $) of Benin and Taxes (in $) of Mongolia?
Ensure brevity in your answer.  -2.86e+11. In the year 2009, what is the difference between the Taxes (in $) in Benin and Taxes (in $) in Singapore?
Offer a terse response. 8.87e+1. In the year 2009, what is the difference between the Taxes (in $) in Benin and Taxes (in $) in St. Kitts and Nevis?
Your answer should be compact. 1.06e+11. In the year 2009, what is the difference between the Taxes (in $) in Mongolia and Taxes (in $) in Singapore?
Offer a terse response. 3.75e+11. In the year 2009, what is the difference between the Taxes (in $) in Mongolia and Taxes (in $) in St. Kitts and Nevis?
Make the answer very short. 3.92e+11. In the year 2009, what is the difference between the Taxes (in $) of Singapore and Taxes (in $) of St. Kitts and Nevis?
Give a very brief answer. 1.70e+1. In the year 2010, what is the difference between the Taxes (in $) of Benin and Taxes (in $) of Mongolia?
Provide a short and direct response. -7.09e+11. In the year 2010, what is the difference between the Taxes (in $) in Benin and Taxes (in $) in Singapore?
Your response must be concise. 8.62e+1. In the year 2010, what is the difference between the Taxes (in $) in Benin and Taxes (in $) in St. Kitts and Nevis?
Your answer should be compact. 1.05e+11. In the year 2010, what is the difference between the Taxes (in $) of Mongolia and Taxes (in $) of Singapore?
Keep it short and to the point. 7.95e+11. In the year 2010, what is the difference between the Taxes (in $) in Mongolia and Taxes (in $) in St. Kitts and Nevis?
Your response must be concise. 8.14e+11. In the year 2010, what is the difference between the Taxes (in $) of Singapore and Taxes (in $) of St. Kitts and Nevis?
Make the answer very short. 1.86e+1. What is the ratio of the Taxes (in $) of Benin in 2001 to that in 2002?
Ensure brevity in your answer.  0.89. What is the ratio of the Taxes (in $) of Mongolia in 2001 to that in 2002?
Your response must be concise. 0.61. What is the ratio of the Taxes (in $) of Singapore in 2001 to that in 2002?
Your response must be concise. 1.14. What is the ratio of the Taxes (in $) in St. Kitts and Nevis in 2001 to that in 2002?
Offer a terse response. 0.93. What is the ratio of the Taxes (in $) of Benin in 2001 to that in 2003?
Provide a succinct answer. 0.9. What is the ratio of the Taxes (in $) in Mongolia in 2001 to that in 2003?
Your response must be concise. 0.3. What is the ratio of the Taxes (in $) in Singapore in 2001 to that in 2003?
Provide a succinct answer. 1.26. What is the ratio of the Taxes (in $) of St. Kitts and Nevis in 2001 to that in 2003?
Keep it short and to the point. 0.9. What is the ratio of the Taxes (in $) of Benin in 2001 to that in 2006?
Offer a terse response. 0.76. What is the ratio of the Taxes (in $) in Mongolia in 2001 to that in 2006?
Keep it short and to the point. 0.05. What is the ratio of the Taxes (in $) of Singapore in 2001 to that in 2006?
Keep it short and to the point. 0.94. What is the ratio of the Taxes (in $) of St. Kitts and Nevis in 2001 to that in 2006?
Offer a very short reply. 0.59. What is the ratio of the Taxes (in $) in Benin in 2001 to that in 2007?
Give a very brief answer. 0.68. What is the ratio of the Taxes (in $) of Mongolia in 2001 to that in 2007?
Offer a terse response. 0.1. What is the ratio of the Taxes (in $) of Singapore in 2001 to that in 2007?
Make the answer very short. 0.83. What is the ratio of the Taxes (in $) in St. Kitts and Nevis in 2001 to that in 2007?
Give a very brief answer. 0.5. What is the ratio of the Taxes (in $) in Benin in 2001 to that in 2008?
Your answer should be very brief. 0.6. What is the ratio of the Taxes (in $) of Mongolia in 2001 to that in 2008?
Your answer should be compact. 0.04. What is the ratio of the Taxes (in $) in Singapore in 2001 to that in 2008?
Provide a succinct answer. 0.64. What is the ratio of the Taxes (in $) of St. Kitts and Nevis in 2001 to that in 2008?
Provide a short and direct response. 0.43. What is the ratio of the Taxes (in $) in Benin in 2001 to that in 2009?
Ensure brevity in your answer.  0.61. What is the ratio of the Taxes (in $) of Mongolia in 2001 to that in 2009?
Your response must be concise. 0.07. What is the ratio of the Taxes (in $) in Singapore in 2001 to that in 2009?
Offer a very short reply. 0.72. What is the ratio of the Taxes (in $) in St. Kitts and Nevis in 2001 to that in 2009?
Provide a short and direct response. 0.39. What is the ratio of the Taxes (in $) of Benin in 2001 to that in 2010?
Ensure brevity in your answer.  0.61. What is the ratio of the Taxes (in $) of Mongolia in 2001 to that in 2010?
Keep it short and to the point. 0.03. What is the ratio of the Taxes (in $) of Singapore in 2001 to that in 2010?
Offer a terse response. 0.66. What is the ratio of the Taxes (in $) of St. Kitts and Nevis in 2001 to that in 2010?
Your response must be concise. 0.62. What is the ratio of the Taxes (in $) of Benin in 2002 to that in 2003?
Offer a terse response. 1.02. What is the ratio of the Taxes (in $) in Mongolia in 2002 to that in 2003?
Offer a very short reply. 0.49. What is the ratio of the Taxes (in $) of Singapore in 2002 to that in 2003?
Your answer should be very brief. 1.11. What is the ratio of the Taxes (in $) of St. Kitts and Nevis in 2002 to that in 2003?
Offer a terse response. 0.97. What is the ratio of the Taxes (in $) of Benin in 2002 to that in 2006?
Ensure brevity in your answer.  0.86. What is the ratio of the Taxes (in $) in Mongolia in 2002 to that in 2006?
Give a very brief answer. 0.09. What is the ratio of the Taxes (in $) of Singapore in 2002 to that in 2006?
Give a very brief answer. 0.82. What is the ratio of the Taxes (in $) in St. Kitts and Nevis in 2002 to that in 2006?
Provide a succinct answer. 0.63. What is the ratio of the Taxes (in $) of Benin in 2002 to that in 2007?
Provide a short and direct response. 0.77. What is the ratio of the Taxes (in $) in Mongolia in 2002 to that in 2007?
Provide a short and direct response. 0.16. What is the ratio of the Taxes (in $) of Singapore in 2002 to that in 2007?
Ensure brevity in your answer.  0.73. What is the ratio of the Taxes (in $) of St. Kitts and Nevis in 2002 to that in 2007?
Offer a very short reply. 0.53. What is the ratio of the Taxes (in $) of Benin in 2002 to that in 2008?
Your answer should be very brief. 0.68. What is the ratio of the Taxes (in $) of Mongolia in 2002 to that in 2008?
Keep it short and to the point. 0.06. What is the ratio of the Taxes (in $) in Singapore in 2002 to that in 2008?
Ensure brevity in your answer.  0.56. What is the ratio of the Taxes (in $) of St. Kitts and Nevis in 2002 to that in 2008?
Make the answer very short. 0.46. What is the ratio of the Taxes (in $) of Benin in 2002 to that in 2009?
Keep it short and to the point. 0.68. What is the ratio of the Taxes (in $) of Mongolia in 2002 to that in 2009?
Give a very brief answer. 0.12. What is the ratio of the Taxes (in $) in Singapore in 2002 to that in 2009?
Provide a succinct answer. 0.63. What is the ratio of the Taxes (in $) in St. Kitts and Nevis in 2002 to that in 2009?
Provide a short and direct response. 0.42. What is the ratio of the Taxes (in $) of Benin in 2002 to that in 2010?
Your answer should be very brief. 0.69. What is the ratio of the Taxes (in $) in Mongolia in 2002 to that in 2010?
Keep it short and to the point. 0.06. What is the ratio of the Taxes (in $) in Singapore in 2002 to that in 2010?
Your response must be concise. 0.58. What is the ratio of the Taxes (in $) of St. Kitts and Nevis in 2002 to that in 2010?
Your answer should be compact. 0.67. What is the ratio of the Taxes (in $) in Benin in 2003 to that in 2006?
Offer a very short reply. 0.84. What is the ratio of the Taxes (in $) in Mongolia in 2003 to that in 2006?
Your answer should be compact. 0.17. What is the ratio of the Taxes (in $) of Singapore in 2003 to that in 2006?
Your answer should be compact. 0.74. What is the ratio of the Taxes (in $) in St. Kitts and Nevis in 2003 to that in 2006?
Ensure brevity in your answer.  0.65. What is the ratio of the Taxes (in $) of Benin in 2003 to that in 2007?
Your answer should be very brief. 0.75. What is the ratio of the Taxes (in $) in Mongolia in 2003 to that in 2007?
Offer a terse response. 0.33. What is the ratio of the Taxes (in $) in Singapore in 2003 to that in 2007?
Give a very brief answer. 0.65. What is the ratio of the Taxes (in $) in St. Kitts and Nevis in 2003 to that in 2007?
Provide a succinct answer. 0.55. What is the ratio of the Taxes (in $) of Benin in 2003 to that in 2008?
Make the answer very short. 0.67. What is the ratio of the Taxes (in $) in Mongolia in 2003 to that in 2008?
Provide a short and direct response. 0.13. What is the ratio of the Taxes (in $) of Singapore in 2003 to that in 2008?
Your response must be concise. 0.51. What is the ratio of the Taxes (in $) in St. Kitts and Nevis in 2003 to that in 2008?
Provide a short and direct response. 0.48. What is the ratio of the Taxes (in $) in Benin in 2003 to that in 2009?
Your answer should be compact. 0.67. What is the ratio of the Taxes (in $) of Mongolia in 2003 to that in 2009?
Ensure brevity in your answer.  0.24. What is the ratio of the Taxes (in $) of Singapore in 2003 to that in 2009?
Offer a terse response. 0.57. What is the ratio of the Taxes (in $) of St. Kitts and Nevis in 2003 to that in 2009?
Your answer should be compact. 0.43. What is the ratio of the Taxes (in $) of Benin in 2003 to that in 2010?
Ensure brevity in your answer.  0.68. What is the ratio of the Taxes (in $) in Mongolia in 2003 to that in 2010?
Offer a very short reply. 0.11. What is the ratio of the Taxes (in $) in Singapore in 2003 to that in 2010?
Your answer should be compact. 0.52. What is the ratio of the Taxes (in $) in St. Kitts and Nevis in 2003 to that in 2010?
Provide a succinct answer. 0.69. What is the ratio of the Taxes (in $) in Benin in 2006 to that in 2007?
Your response must be concise. 0.89. What is the ratio of the Taxes (in $) of Mongolia in 2006 to that in 2007?
Make the answer very short. 1.91. What is the ratio of the Taxes (in $) of Singapore in 2006 to that in 2007?
Your answer should be very brief. 0.88. What is the ratio of the Taxes (in $) in St. Kitts and Nevis in 2006 to that in 2007?
Provide a short and direct response. 0.85. What is the ratio of the Taxes (in $) of Benin in 2006 to that in 2008?
Make the answer very short. 0.79. What is the ratio of the Taxes (in $) of Mongolia in 2006 to that in 2008?
Make the answer very short. 0.73. What is the ratio of the Taxes (in $) in Singapore in 2006 to that in 2008?
Provide a succinct answer. 0.68. What is the ratio of the Taxes (in $) of St. Kitts and Nevis in 2006 to that in 2008?
Make the answer very short. 0.73. What is the ratio of the Taxes (in $) of Benin in 2006 to that in 2009?
Keep it short and to the point. 0.8. What is the ratio of the Taxes (in $) of Mongolia in 2006 to that in 2009?
Keep it short and to the point. 1.38. What is the ratio of the Taxes (in $) of Singapore in 2006 to that in 2009?
Provide a succinct answer. 0.77. What is the ratio of the Taxes (in $) in Benin in 2006 to that in 2010?
Offer a terse response. 0.81. What is the ratio of the Taxes (in $) of Mongolia in 2006 to that in 2010?
Your response must be concise. 0.66. What is the ratio of the Taxes (in $) in Singapore in 2006 to that in 2010?
Offer a very short reply. 0.71. What is the ratio of the Taxes (in $) of St. Kitts and Nevis in 2006 to that in 2010?
Provide a succinct answer. 1.06. What is the ratio of the Taxes (in $) of Benin in 2007 to that in 2008?
Provide a succinct answer. 0.89. What is the ratio of the Taxes (in $) of Mongolia in 2007 to that in 2008?
Your answer should be very brief. 0.38. What is the ratio of the Taxes (in $) of Singapore in 2007 to that in 2008?
Your answer should be compact. 0.78. What is the ratio of the Taxes (in $) of St. Kitts and Nevis in 2007 to that in 2008?
Provide a succinct answer. 0.86. What is the ratio of the Taxes (in $) in Benin in 2007 to that in 2009?
Your answer should be compact. 0.89. What is the ratio of the Taxes (in $) of Mongolia in 2007 to that in 2009?
Offer a very short reply. 0.72. What is the ratio of the Taxes (in $) of Singapore in 2007 to that in 2009?
Make the answer very short. 0.87. What is the ratio of the Taxes (in $) in St. Kitts and Nevis in 2007 to that in 2009?
Provide a succinct answer. 0.79. What is the ratio of the Taxes (in $) in Benin in 2007 to that in 2010?
Your answer should be compact. 0.9. What is the ratio of the Taxes (in $) of Mongolia in 2007 to that in 2010?
Give a very brief answer. 0.35. What is the ratio of the Taxes (in $) of Singapore in 2007 to that in 2010?
Offer a terse response. 0.8. What is the ratio of the Taxes (in $) of St. Kitts and Nevis in 2007 to that in 2010?
Your answer should be very brief. 1.25. What is the ratio of the Taxes (in $) in Benin in 2008 to that in 2009?
Offer a very short reply. 1.01. What is the ratio of the Taxes (in $) of Mongolia in 2008 to that in 2009?
Offer a terse response. 1.9. What is the ratio of the Taxes (in $) of Singapore in 2008 to that in 2009?
Your answer should be very brief. 1.12. What is the ratio of the Taxes (in $) in St. Kitts and Nevis in 2008 to that in 2009?
Offer a very short reply. 0.91. What is the ratio of the Taxes (in $) of Benin in 2008 to that in 2010?
Provide a short and direct response. 1.02. What is the ratio of the Taxes (in $) in Mongolia in 2008 to that in 2010?
Keep it short and to the point. 0.91. What is the ratio of the Taxes (in $) of Singapore in 2008 to that in 2010?
Your answer should be very brief. 1.03. What is the ratio of the Taxes (in $) of St. Kitts and Nevis in 2008 to that in 2010?
Make the answer very short. 1.46. What is the ratio of the Taxes (in $) in Benin in 2009 to that in 2010?
Provide a short and direct response. 1.01. What is the ratio of the Taxes (in $) of Mongolia in 2009 to that in 2010?
Offer a very short reply. 0.48. What is the ratio of the Taxes (in $) in Singapore in 2009 to that in 2010?
Your answer should be compact. 0.92. What is the ratio of the Taxes (in $) of St. Kitts and Nevis in 2009 to that in 2010?
Give a very brief answer. 1.59. What is the difference between the highest and the second highest Taxes (in $) of Benin?
Ensure brevity in your answer.  8.11e+08. What is the difference between the highest and the second highest Taxes (in $) in Mongolia?
Provide a succinct answer. 7.00e+1. What is the difference between the highest and the second highest Taxes (in $) in Singapore?
Provide a short and direct response. 6.11e+08. What is the difference between the highest and the second highest Taxes (in $) in St. Kitts and Nevis?
Offer a terse response. 1.28e+07. What is the difference between the highest and the lowest Taxes (in $) of Benin?
Your answer should be very brief. 4.24e+1. What is the difference between the highest and the lowest Taxes (in $) in Mongolia?
Your answer should be compact. 7.86e+11. What is the difference between the highest and the lowest Taxes (in $) of Singapore?
Provide a short and direct response. 9.47e+09. What is the difference between the highest and the lowest Taxes (in $) of St. Kitts and Nevis?
Keep it short and to the point. 8.99e+07. 